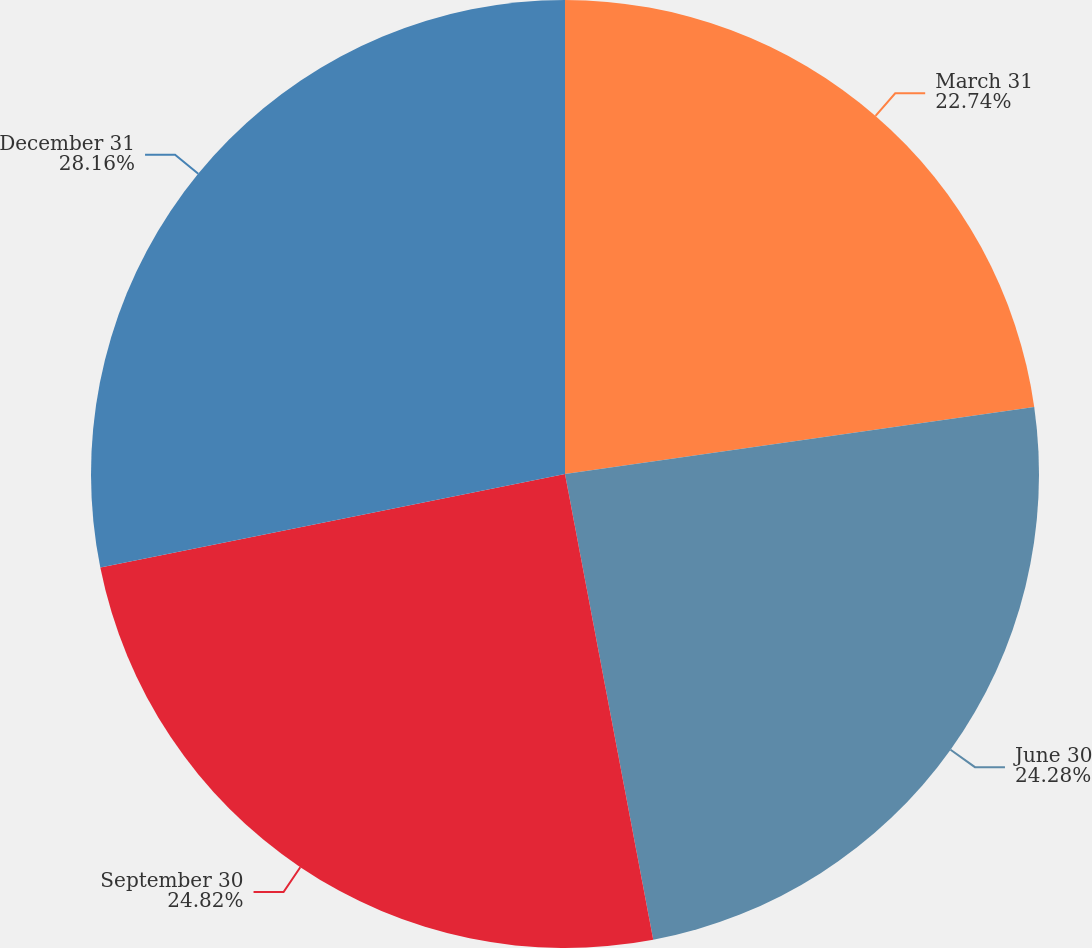Convert chart. <chart><loc_0><loc_0><loc_500><loc_500><pie_chart><fcel>March 31<fcel>June 30<fcel>September 30<fcel>December 31<nl><fcel>22.74%<fcel>24.28%<fcel>24.82%<fcel>28.16%<nl></chart> 